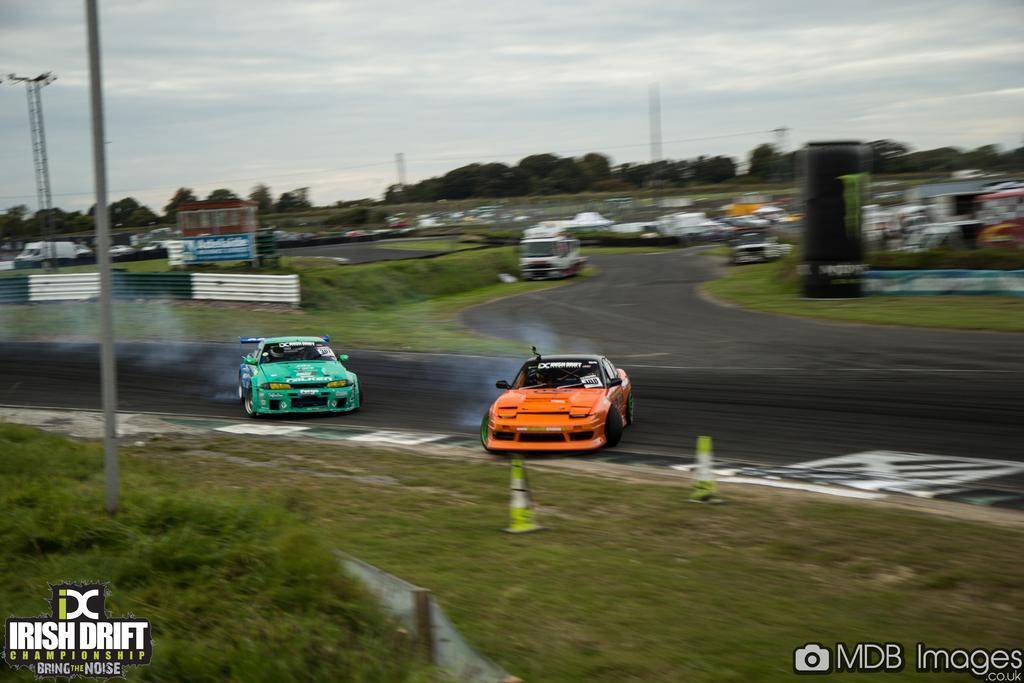Please provide a concise description of this image. In this image we can see two racing cars on the road and we can also see vehicles, trees, poles, sky and watermarks at the bottom. 